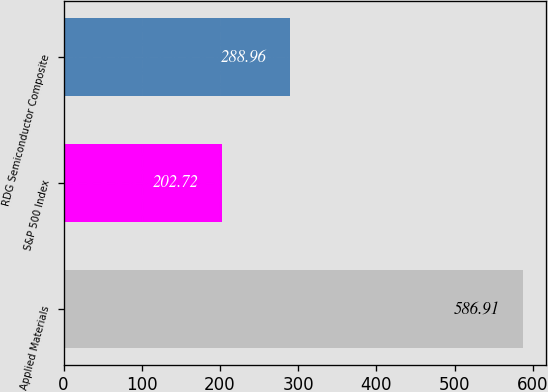<chart> <loc_0><loc_0><loc_500><loc_500><bar_chart><fcel>Applied Materials<fcel>S&P 500 Index<fcel>RDG Semiconductor Composite<nl><fcel>586.91<fcel>202.72<fcel>288.96<nl></chart> 